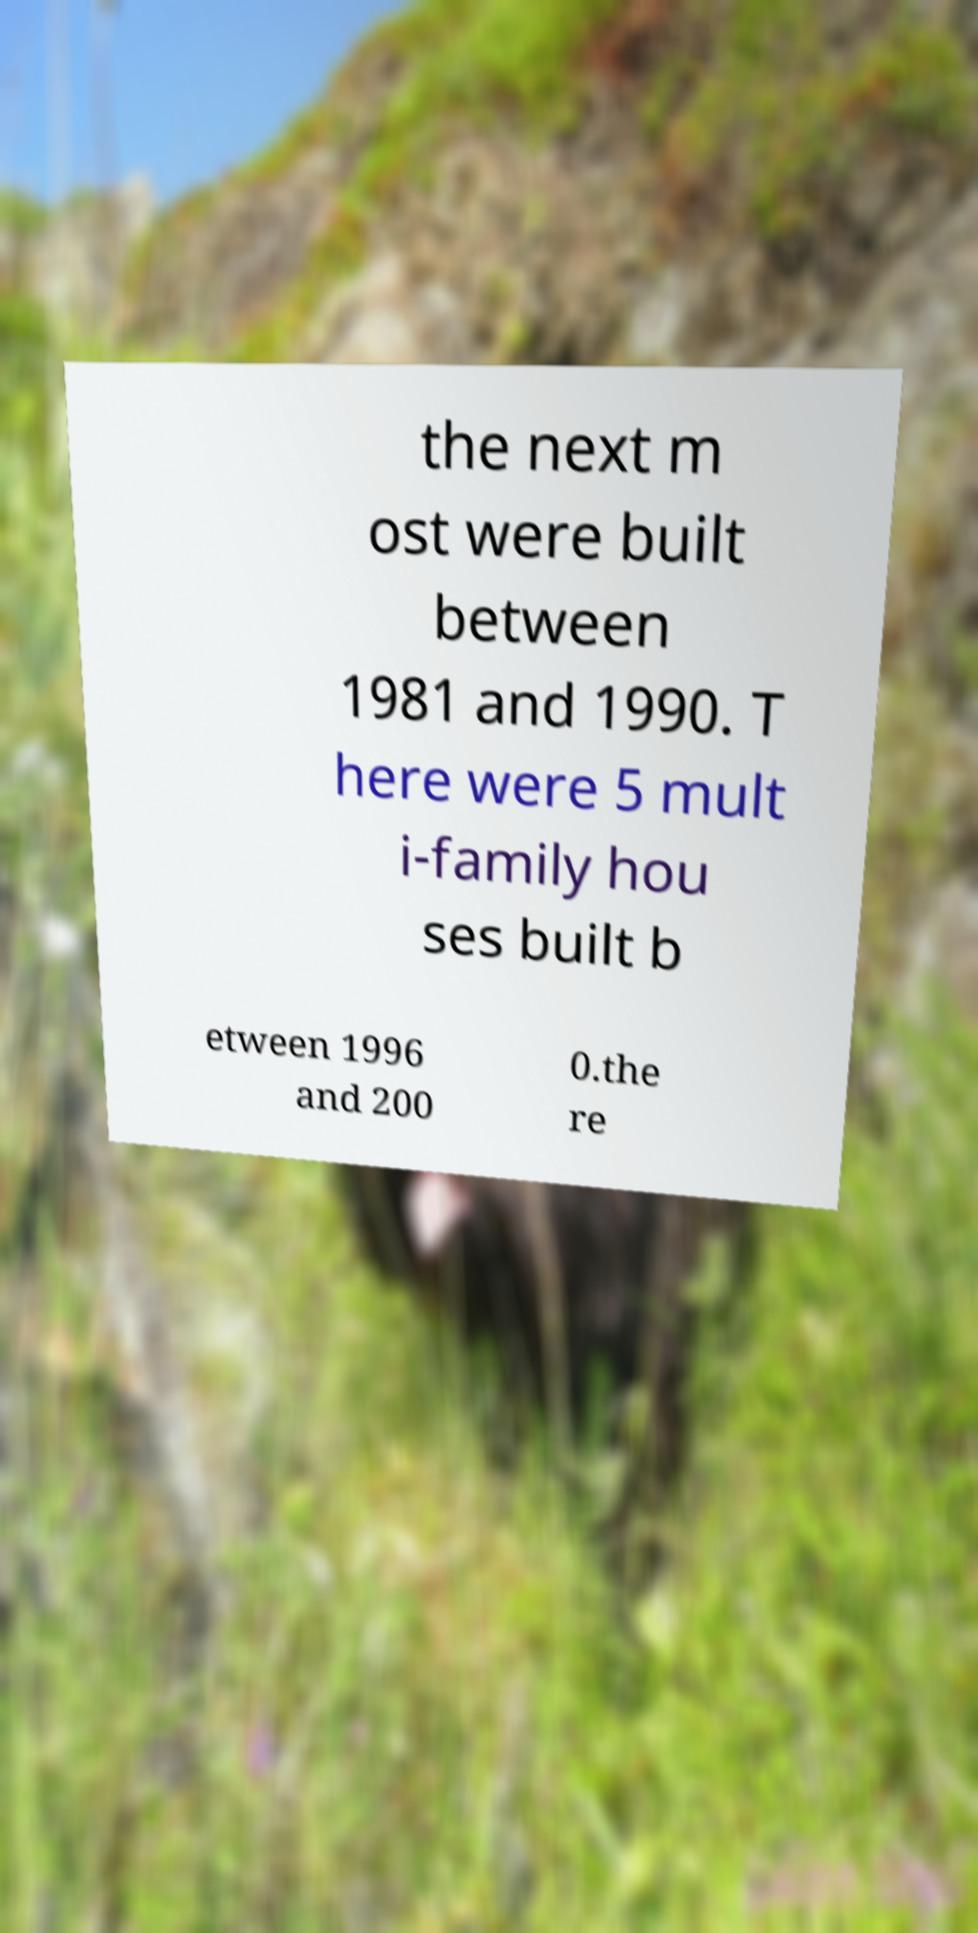Can you accurately transcribe the text from the provided image for me? the next m ost were built between 1981 and 1990. T here were 5 mult i-family hou ses built b etween 1996 and 200 0.the re 